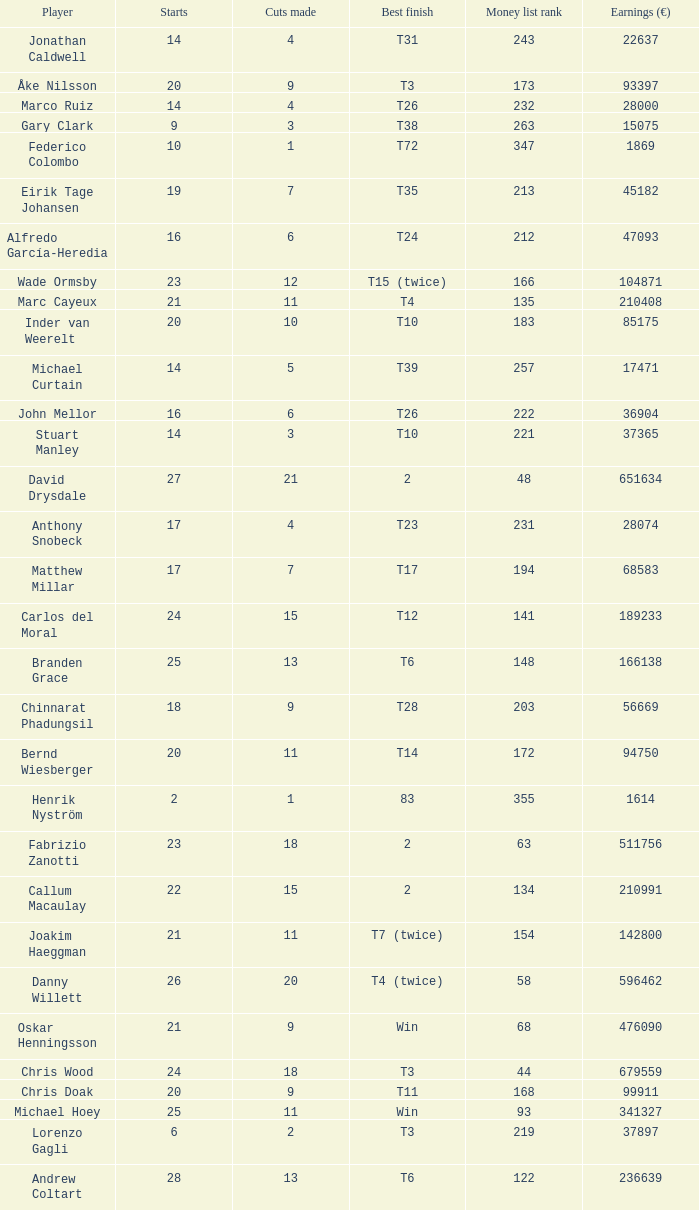How many cuts did the player who earned 210408 Euro make? 11.0. 